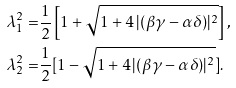<formula> <loc_0><loc_0><loc_500><loc_500>\lambda _ { 1 } ^ { 2 } = & \frac { 1 } { 2 } \left [ 1 + \sqrt { 1 + 4 \, | ( \beta \gamma - \alpha \delta ) | ^ { 2 } } \right ] , \\ \lambda _ { 2 } ^ { 2 } = & \frac { 1 } { 2 } [ 1 - \sqrt { 1 + 4 \, | ( \beta \gamma - \alpha \delta ) | ^ { 2 } } ] .</formula> 